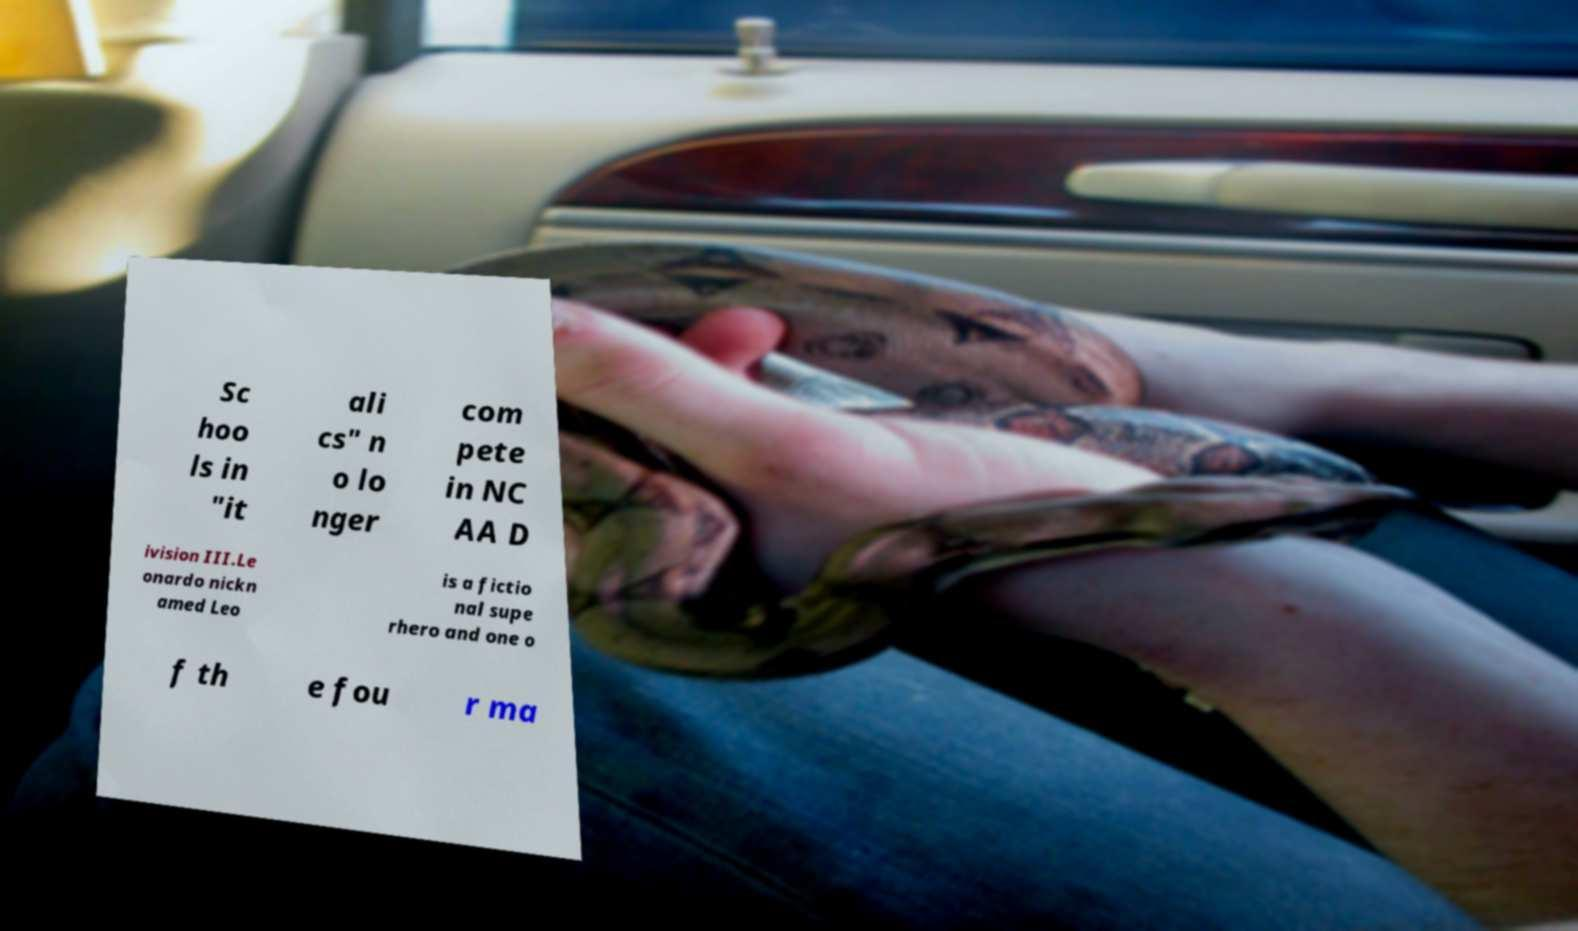I need the written content from this picture converted into text. Can you do that? Sc hoo ls in "it ali cs" n o lo nger com pete in NC AA D ivision III.Le onardo nickn amed Leo is a fictio nal supe rhero and one o f th e fou r ma 